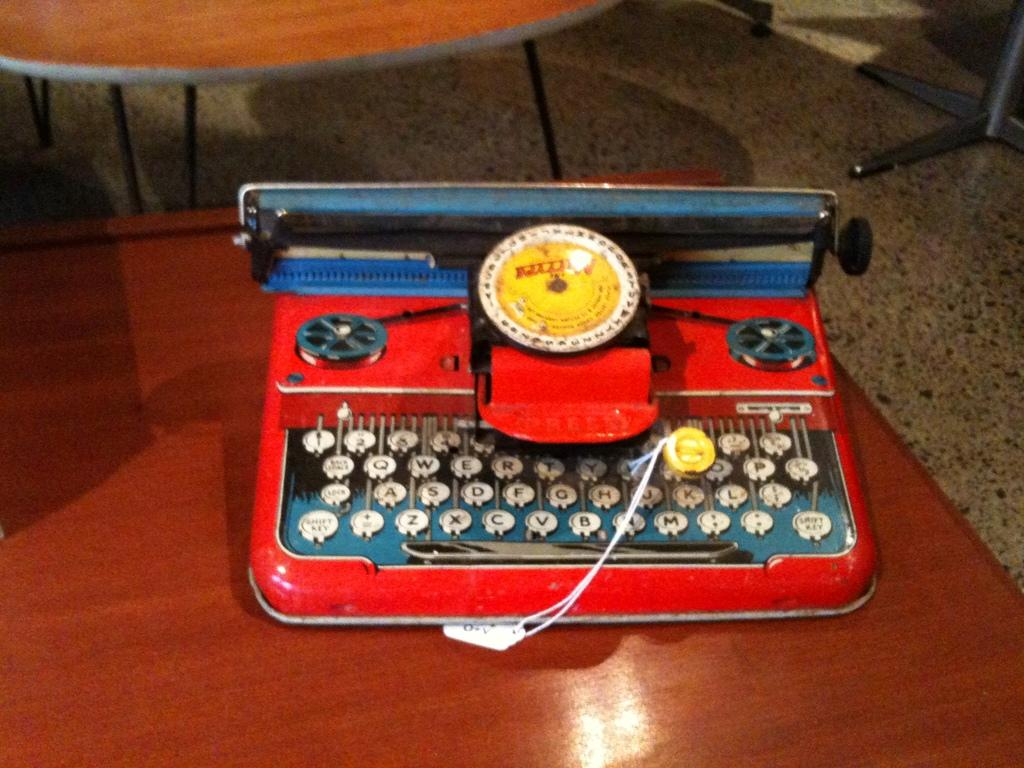<image>
Relay a brief, clear account of the picture shown. A very old colorful red typewriter sits on a wood style desk and has shift keys on the left and right side. 